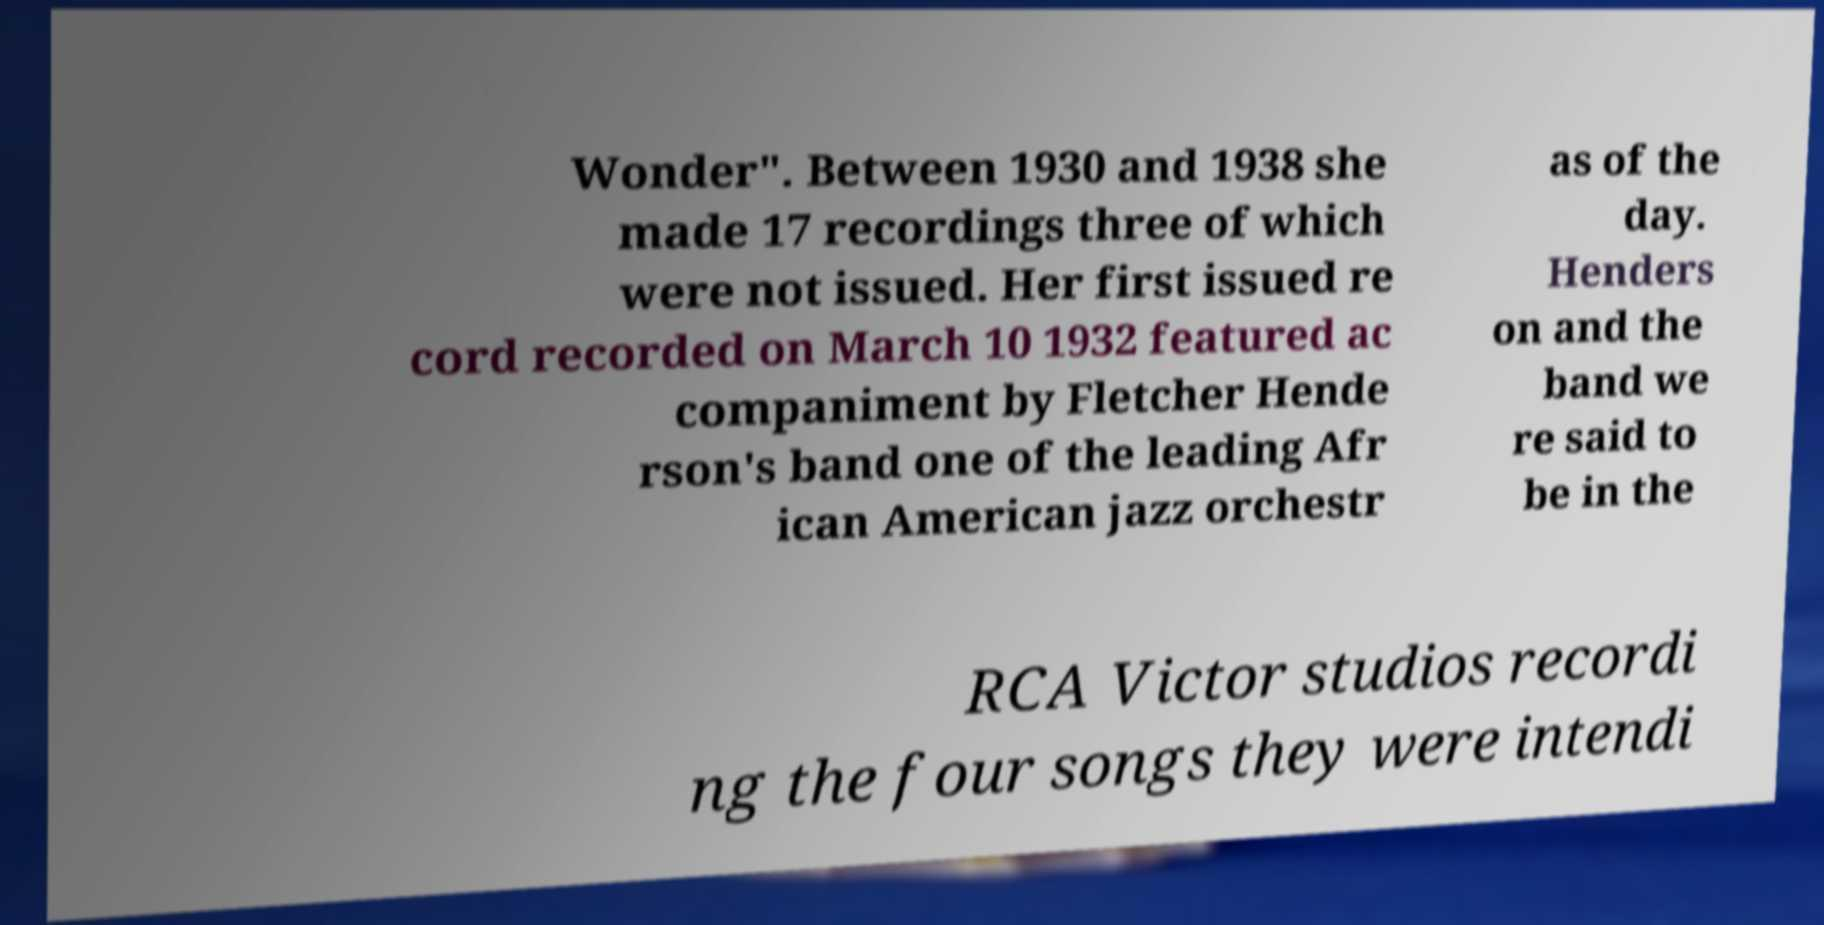Can you read and provide the text displayed in the image?This photo seems to have some interesting text. Can you extract and type it out for me? Wonder". Between 1930 and 1938 she made 17 recordings three of which were not issued. Her first issued re cord recorded on March 10 1932 featured ac companiment by Fletcher Hende rson's band one of the leading Afr ican American jazz orchestr as of the day. Henders on and the band we re said to be in the RCA Victor studios recordi ng the four songs they were intendi 